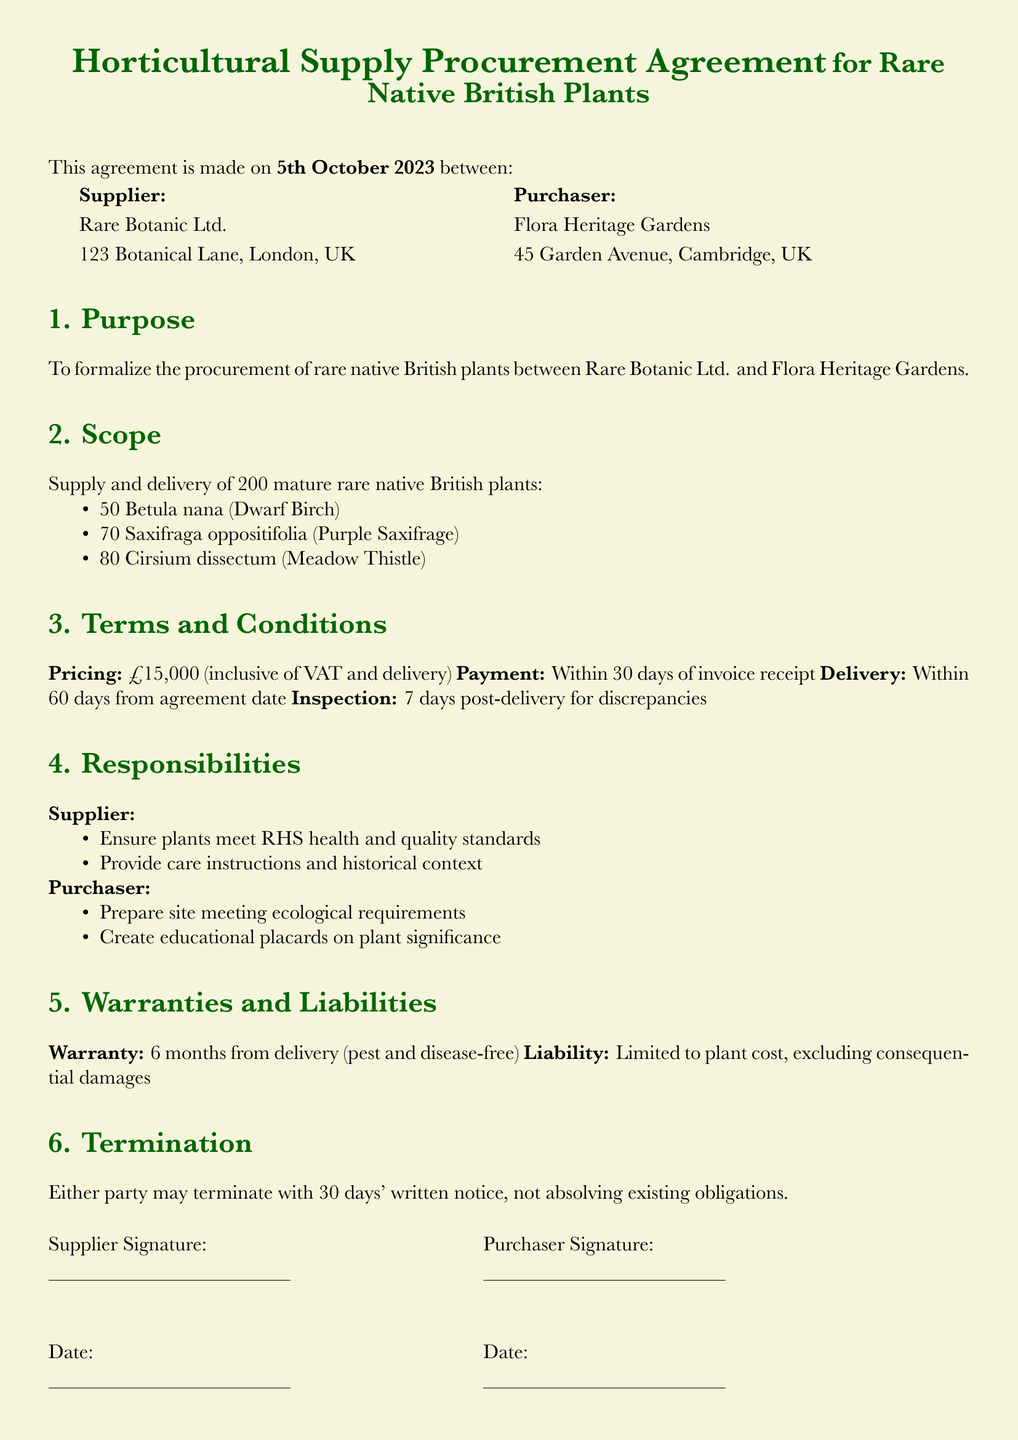What is the date of the agreement? The date of the agreement is stated at the beginning of the document.
Answer: 5th October 2023 Who is the supplier? The name of the supplier is given in the introductory section of the document.
Answer: Rare Botanic Ltd How many Cirsium dissectum are to be supplied? The document specifies the quantity of each type of plant in the scope section.
Answer: 80 What is the total cost of the plants? The total cost is listed under terms and conditions as the pricing section.
Answer: £15,000 What is the warranty period? The duration of the warranty can be found in the warranties and liabilities section.
Answer: 6 months What is the payment term? The payment obligation is specified under terms and conditions in the document.
Answer: Within 30 days of invoice receipt What does the supplier need to ensure regarding the plants? The responsibilities of the supplier detail their obligations in the document.
Answer: Meet RHS health and quality standards What can trigger termination of the agreement? The section on termination outlines the conditions under which the contract can be ended.
Answer: 30 days' written notice What is the delivery timeframe? The delivery requirement is included in the terms and conditions section of the document.
Answer: Within 60 days from agreement date 